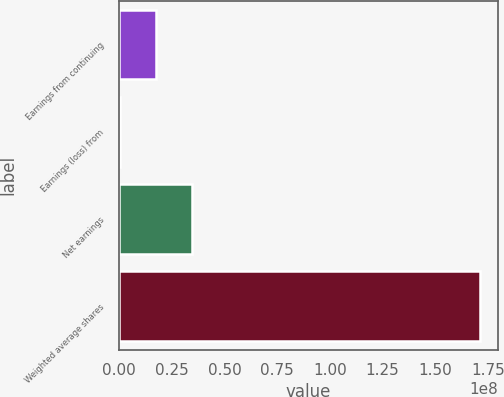Convert chart. <chart><loc_0><loc_0><loc_500><loc_500><bar_chart><fcel>Earnings from continuing<fcel>Earnings (loss) from<fcel>Net earnings<fcel>Weighted average shares<nl><fcel>1.73121e+07<fcel>205602<fcel>3.44187e+07<fcel>1.71271e+08<nl></chart> 